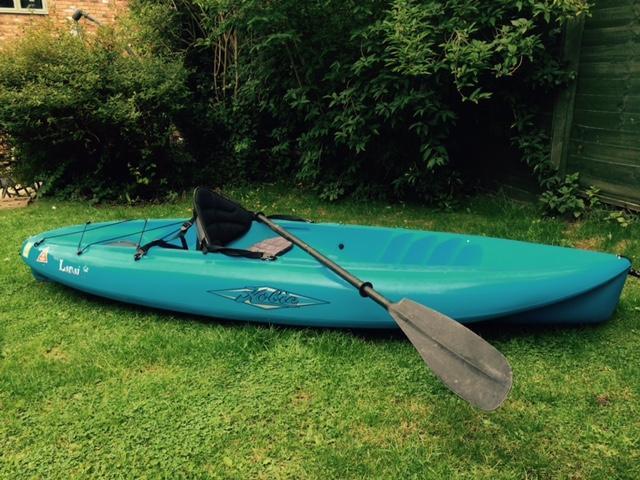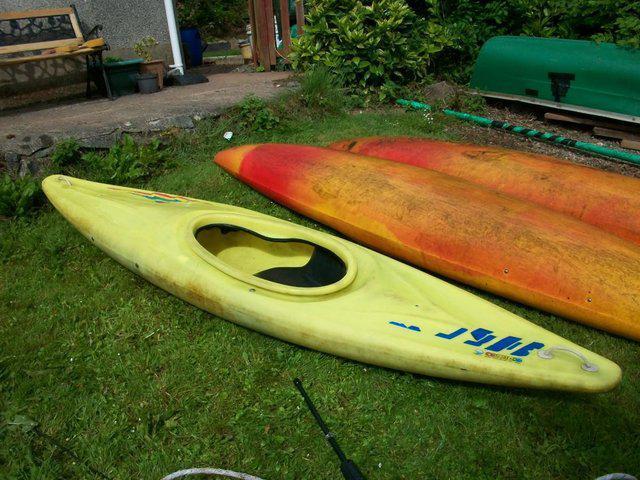The first image is the image on the left, the second image is the image on the right. Assess this claim about the two images: "The canoe is facing left in both images.". Correct or not? Answer yes or no. Yes. The first image is the image on the left, the second image is the image on the right. Given the left and right images, does the statement "there is an oar laying across the boat" hold true? Answer yes or no. Yes. 